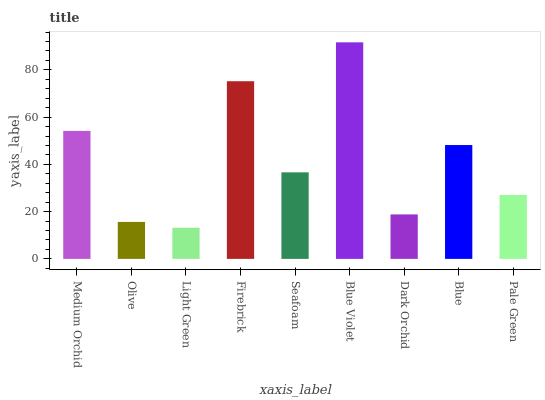Is Light Green the minimum?
Answer yes or no. Yes. Is Blue Violet the maximum?
Answer yes or no. Yes. Is Olive the minimum?
Answer yes or no. No. Is Olive the maximum?
Answer yes or no. No. Is Medium Orchid greater than Olive?
Answer yes or no. Yes. Is Olive less than Medium Orchid?
Answer yes or no. Yes. Is Olive greater than Medium Orchid?
Answer yes or no. No. Is Medium Orchid less than Olive?
Answer yes or no. No. Is Seafoam the high median?
Answer yes or no. Yes. Is Seafoam the low median?
Answer yes or no. Yes. Is Olive the high median?
Answer yes or no. No. Is Blue Violet the low median?
Answer yes or no. No. 